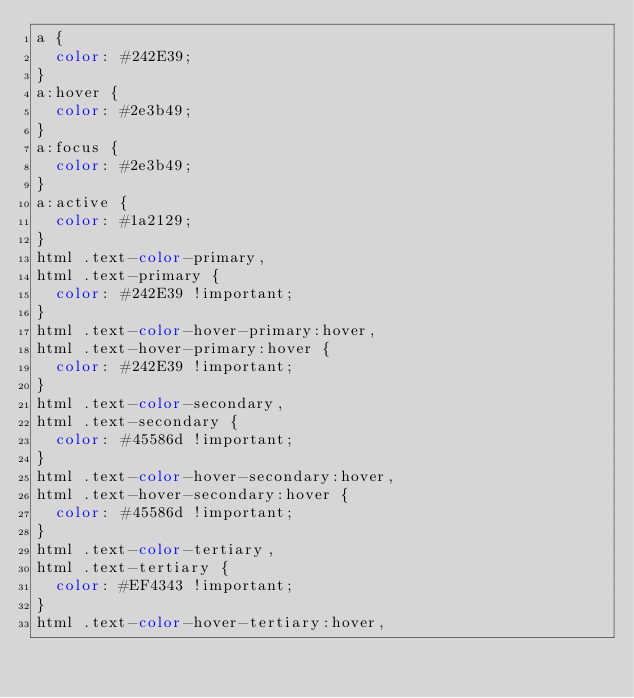<code> <loc_0><loc_0><loc_500><loc_500><_CSS_>a {
  color: #242E39;
}
a:hover {
  color: #2e3b49;
}
a:focus {
  color: #2e3b49;
}
a:active {
  color: #1a2129;
}
html .text-color-primary,
html .text-primary {
  color: #242E39 !important;
}
html .text-color-hover-primary:hover,
html .text-hover-primary:hover {
  color: #242E39 !important;
}
html .text-color-secondary,
html .text-secondary {
  color: #45586d !important;
}
html .text-color-hover-secondary:hover,
html .text-hover-secondary:hover {
  color: #45586d !important;
}
html .text-color-tertiary,
html .text-tertiary {
  color: #EF4343 !important;
}
html .text-color-hover-tertiary:hover,</code> 